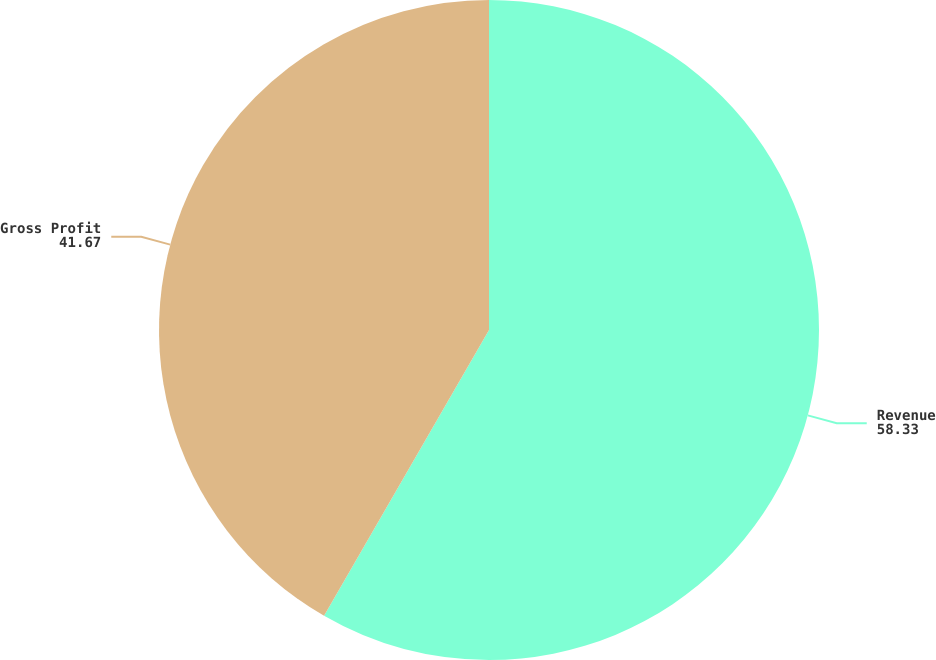Convert chart. <chart><loc_0><loc_0><loc_500><loc_500><pie_chart><fcel>Revenue<fcel>Gross Profit<nl><fcel>58.33%<fcel>41.67%<nl></chart> 